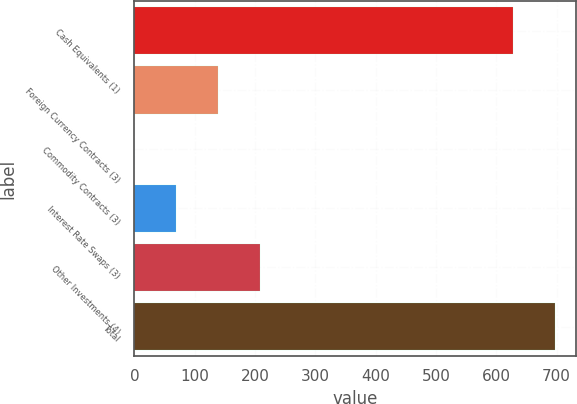<chart> <loc_0><loc_0><loc_500><loc_500><bar_chart><fcel>Cash Equivalents (1)<fcel>Foreign Currency Contracts (3)<fcel>Commodity Contracts (3)<fcel>Interest Rate Swaps (3)<fcel>Other Investments (4)<fcel>Total<nl><fcel>628.3<fcel>139.48<fcel>0.24<fcel>69.86<fcel>209.1<fcel>697.92<nl></chart> 